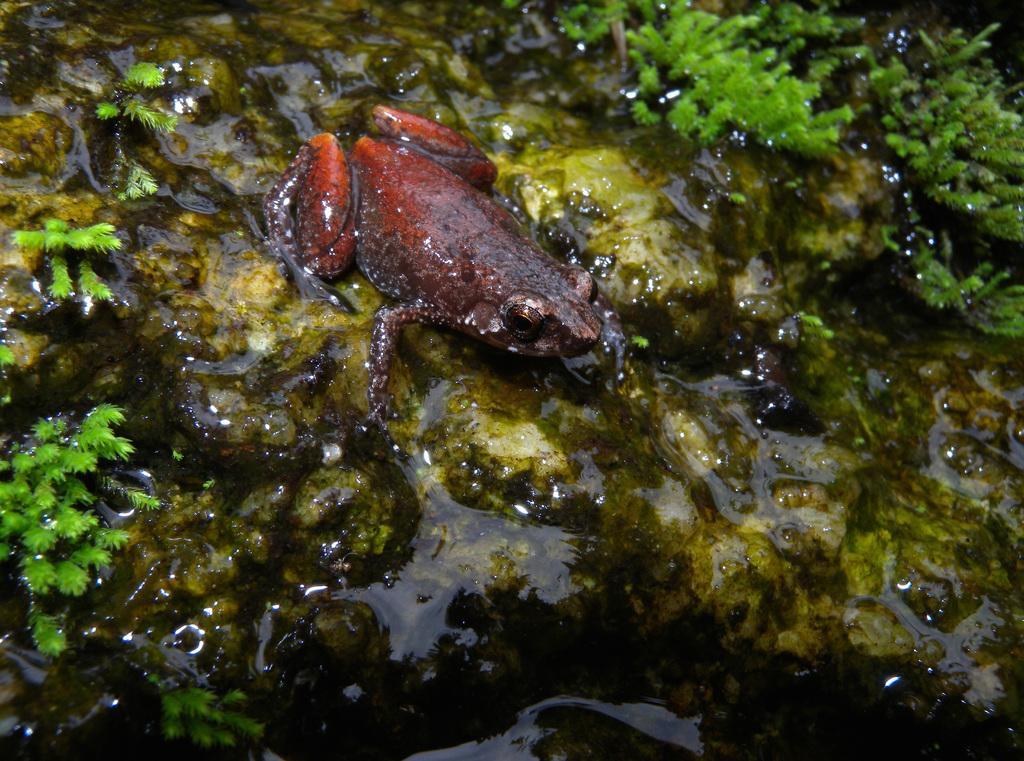Could you give a brief overview of what you see in this image? In this picture we can see the water, tiny plants and a frog. Stones are visible. 